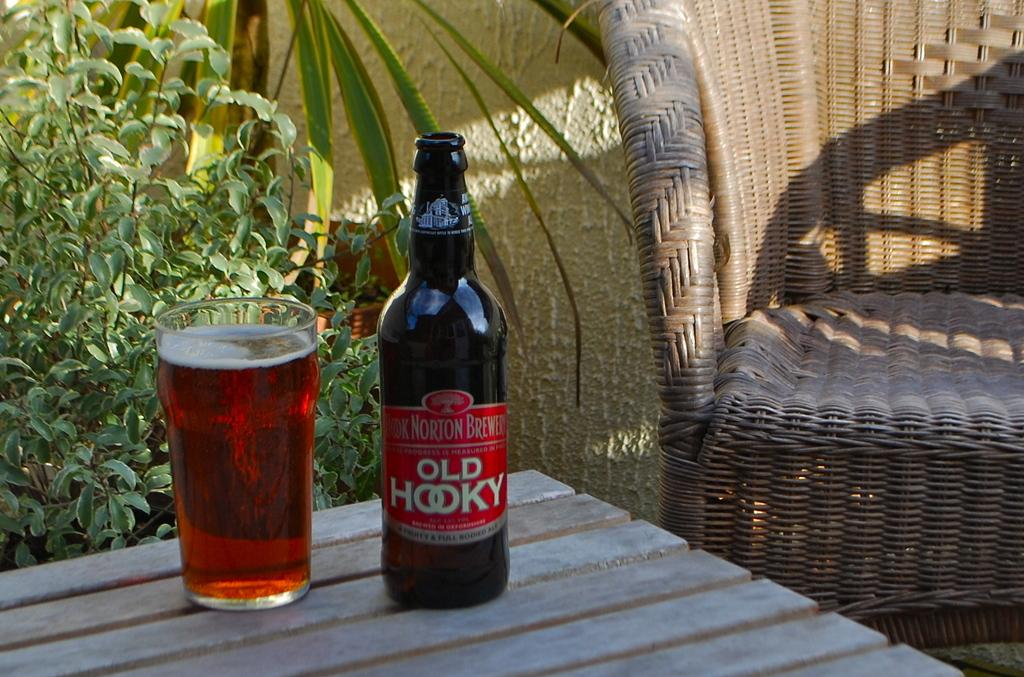<image>
Summarize the visual content of the image. bottle of old hooky next to a glassful on a table next to a wicker chair 